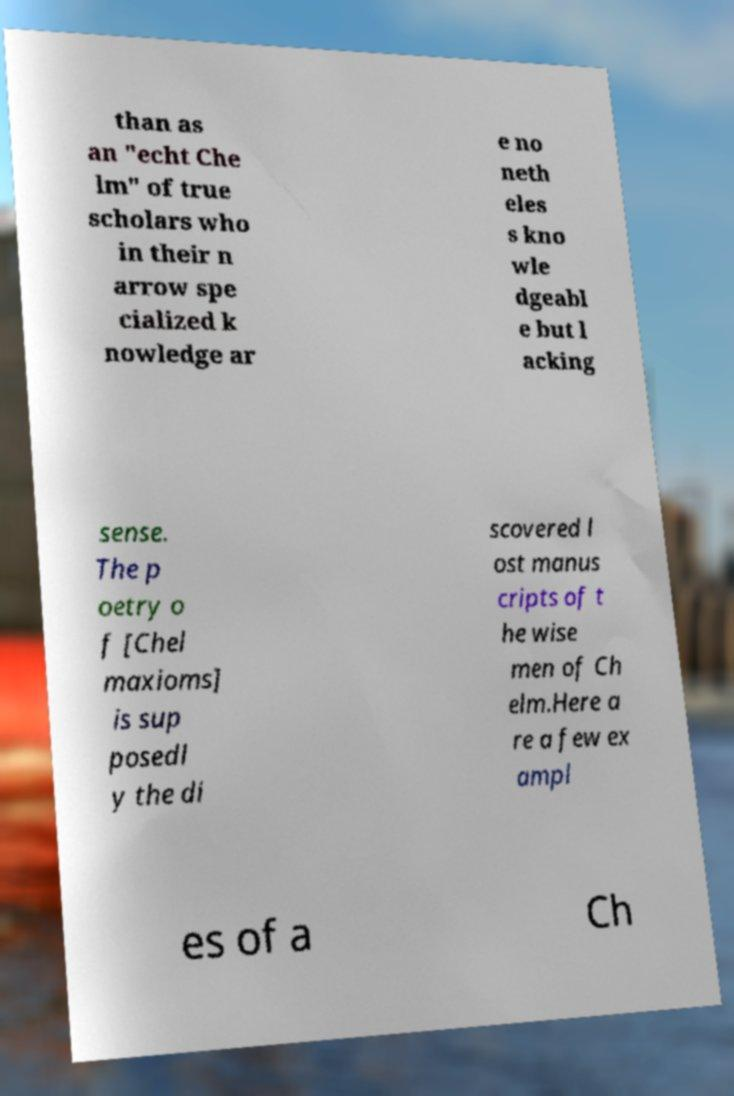Please read and relay the text visible in this image. What does it say? than as an "echt Che lm" of true scholars who in their n arrow spe cialized k nowledge ar e no neth eles s kno wle dgeabl e but l acking sense. The p oetry o f [Chel maxioms] is sup posedl y the di scovered l ost manus cripts of t he wise men of Ch elm.Here a re a few ex ampl es of a Ch 